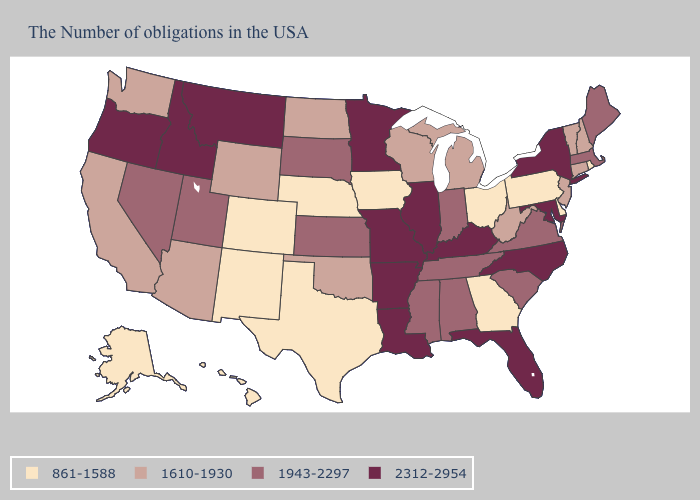Which states have the highest value in the USA?
Be succinct. New York, Maryland, North Carolina, Florida, Kentucky, Illinois, Louisiana, Missouri, Arkansas, Minnesota, Montana, Idaho, Oregon. Does Utah have the highest value in the USA?
Write a very short answer. No. Name the states that have a value in the range 1610-1930?
Short answer required. New Hampshire, Vermont, Connecticut, New Jersey, West Virginia, Michigan, Wisconsin, Oklahoma, North Dakota, Wyoming, Arizona, California, Washington. What is the value of Texas?
Be succinct. 861-1588. Name the states that have a value in the range 1943-2297?
Be succinct. Maine, Massachusetts, Virginia, South Carolina, Indiana, Alabama, Tennessee, Mississippi, Kansas, South Dakota, Utah, Nevada. Which states hav the highest value in the South?
Keep it brief. Maryland, North Carolina, Florida, Kentucky, Louisiana, Arkansas. What is the value of Maine?
Short answer required. 1943-2297. Name the states that have a value in the range 1943-2297?
Write a very short answer. Maine, Massachusetts, Virginia, South Carolina, Indiana, Alabama, Tennessee, Mississippi, Kansas, South Dakota, Utah, Nevada. Among the states that border Pennsylvania , which have the highest value?
Write a very short answer. New York, Maryland. What is the value of Alabama?
Give a very brief answer. 1943-2297. What is the lowest value in states that border Maine?
Write a very short answer. 1610-1930. Does Indiana have the highest value in the MidWest?
Short answer required. No. What is the value of Delaware?
Answer briefly. 861-1588. What is the value of Louisiana?
Answer briefly. 2312-2954. What is the lowest value in the USA?
Quick response, please. 861-1588. 